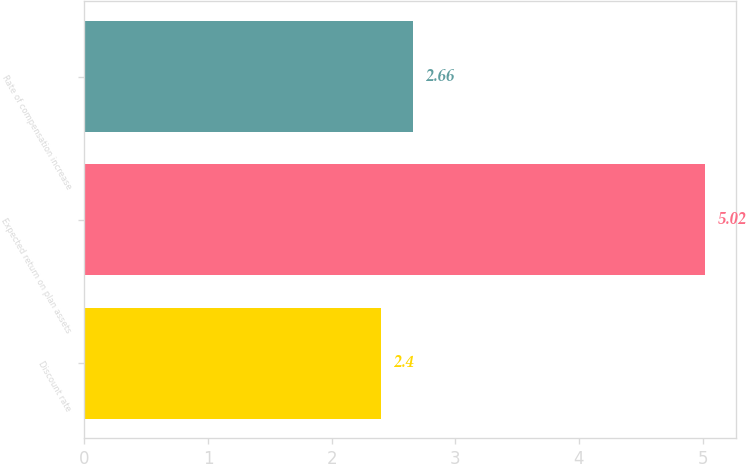<chart> <loc_0><loc_0><loc_500><loc_500><bar_chart><fcel>Discount rate<fcel>Expected return on plan assets<fcel>Rate of compensation increase<nl><fcel>2.4<fcel>5.02<fcel>2.66<nl></chart> 